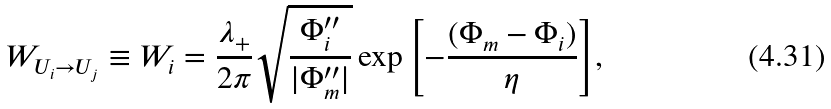<formula> <loc_0><loc_0><loc_500><loc_500>W _ { U _ { i } \rightarrow U _ { j } } \equiv W _ { i } = \frac { \lambda _ { + } } { 2 \pi } \sqrt { \frac { \Phi ^ { \prime \prime } _ { i } } { | \Phi ^ { \prime \prime } _ { m } | } } \exp { \left [ - \frac { ( \Phi _ { m } - \Phi _ { i } ) } { \eta } \right ] } ,</formula> 